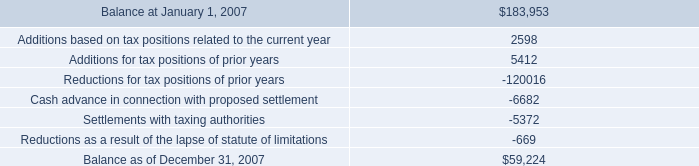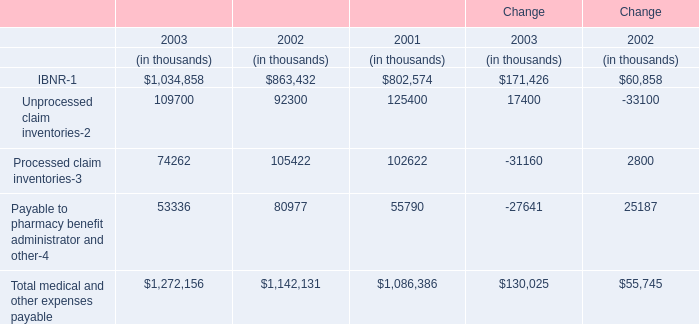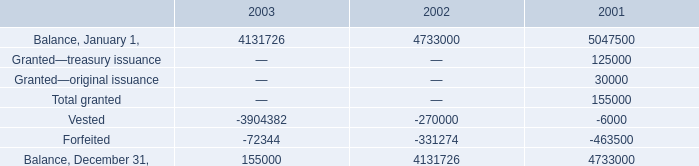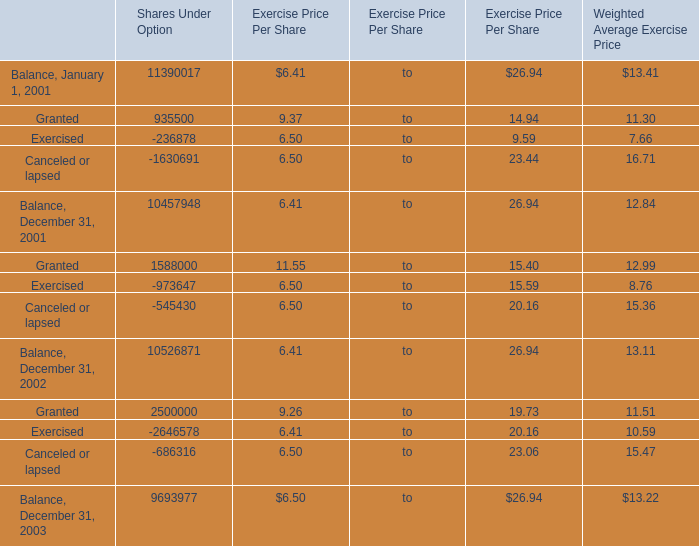What is the growing rate of Vested in the years with the leastForfeited? (in %) 
Computations: ((270000 - 6000) / 6000)
Answer: 44.0. 